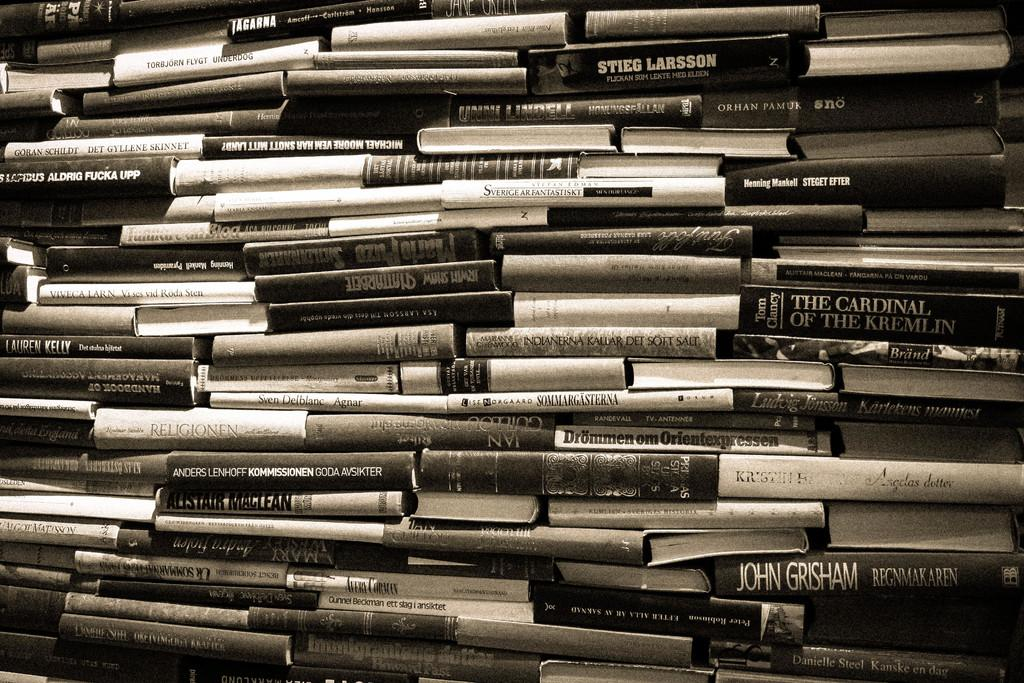<image>
Describe the image concisely. the name John is on the book among many other ones 